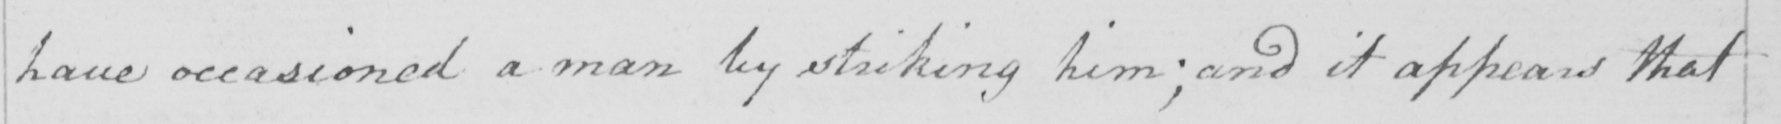What does this handwritten line say? have occasioned a man by striking him ; and it appears that 